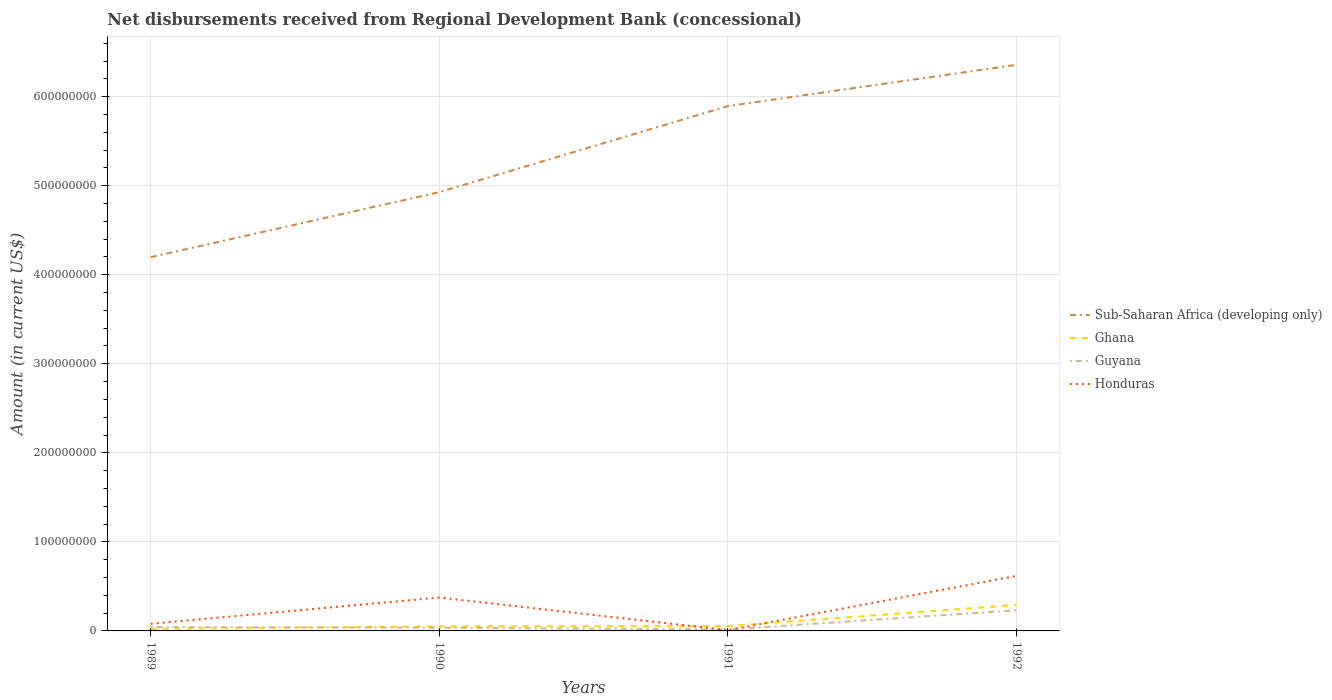How many different coloured lines are there?
Your response must be concise. 4. Is the number of lines equal to the number of legend labels?
Ensure brevity in your answer.  Yes. Across all years, what is the maximum amount of disbursements received from Regional Development Bank in Honduras?
Keep it short and to the point. 9.04e+05. In which year was the amount of disbursements received from Regional Development Bank in Honduras maximum?
Your answer should be very brief. 1991. What is the total amount of disbursements received from Regional Development Bank in Ghana in the graph?
Ensure brevity in your answer.  -2.36e+07. What is the difference between the highest and the second highest amount of disbursements received from Regional Development Bank in Guyana?
Your response must be concise. 2.15e+07. What is the difference between the highest and the lowest amount of disbursements received from Regional Development Bank in Sub-Saharan Africa (developing only)?
Provide a short and direct response. 2. Are the values on the major ticks of Y-axis written in scientific E-notation?
Your answer should be compact. No. Does the graph contain grids?
Provide a short and direct response. Yes. Where does the legend appear in the graph?
Keep it short and to the point. Center right. How many legend labels are there?
Your answer should be compact. 4. How are the legend labels stacked?
Make the answer very short. Vertical. What is the title of the graph?
Keep it short and to the point. Net disbursements received from Regional Development Bank (concessional). Does "Suriname" appear as one of the legend labels in the graph?
Keep it short and to the point. No. What is the label or title of the X-axis?
Offer a very short reply. Years. What is the Amount (in current US$) in Sub-Saharan Africa (developing only) in 1989?
Your answer should be very brief. 4.20e+08. What is the Amount (in current US$) of Ghana in 1989?
Your response must be concise. 2.13e+06. What is the Amount (in current US$) in Guyana in 1989?
Make the answer very short. 4.30e+06. What is the Amount (in current US$) of Honduras in 1989?
Give a very brief answer. 8.04e+06. What is the Amount (in current US$) in Sub-Saharan Africa (developing only) in 1990?
Provide a succinct answer. 4.93e+08. What is the Amount (in current US$) in Ghana in 1990?
Keep it short and to the point. 5.26e+06. What is the Amount (in current US$) of Guyana in 1990?
Your answer should be very brief. 3.54e+06. What is the Amount (in current US$) of Honduras in 1990?
Offer a terse response. 3.75e+07. What is the Amount (in current US$) of Sub-Saharan Africa (developing only) in 1991?
Keep it short and to the point. 5.89e+08. What is the Amount (in current US$) of Ghana in 1991?
Ensure brevity in your answer.  5.51e+06. What is the Amount (in current US$) in Guyana in 1991?
Provide a short and direct response. 1.63e+06. What is the Amount (in current US$) of Honduras in 1991?
Your response must be concise. 9.04e+05. What is the Amount (in current US$) in Sub-Saharan Africa (developing only) in 1992?
Your answer should be compact. 6.36e+08. What is the Amount (in current US$) in Ghana in 1992?
Provide a short and direct response. 2.91e+07. What is the Amount (in current US$) of Guyana in 1992?
Offer a terse response. 2.32e+07. What is the Amount (in current US$) of Honduras in 1992?
Make the answer very short. 6.19e+07. Across all years, what is the maximum Amount (in current US$) of Sub-Saharan Africa (developing only)?
Provide a short and direct response. 6.36e+08. Across all years, what is the maximum Amount (in current US$) in Ghana?
Offer a terse response. 2.91e+07. Across all years, what is the maximum Amount (in current US$) of Guyana?
Your response must be concise. 2.32e+07. Across all years, what is the maximum Amount (in current US$) in Honduras?
Offer a very short reply. 6.19e+07. Across all years, what is the minimum Amount (in current US$) of Sub-Saharan Africa (developing only)?
Give a very brief answer. 4.20e+08. Across all years, what is the minimum Amount (in current US$) of Ghana?
Ensure brevity in your answer.  2.13e+06. Across all years, what is the minimum Amount (in current US$) in Guyana?
Keep it short and to the point. 1.63e+06. Across all years, what is the minimum Amount (in current US$) of Honduras?
Your response must be concise. 9.04e+05. What is the total Amount (in current US$) of Sub-Saharan Africa (developing only) in the graph?
Keep it short and to the point. 2.14e+09. What is the total Amount (in current US$) in Ghana in the graph?
Make the answer very short. 4.20e+07. What is the total Amount (in current US$) in Guyana in the graph?
Offer a terse response. 3.26e+07. What is the total Amount (in current US$) of Honduras in the graph?
Keep it short and to the point. 1.08e+08. What is the difference between the Amount (in current US$) of Sub-Saharan Africa (developing only) in 1989 and that in 1990?
Provide a succinct answer. -7.30e+07. What is the difference between the Amount (in current US$) of Ghana in 1989 and that in 1990?
Your response must be concise. -3.12e+06. What is the difference between the Amount (in current US$) of Guyana in 1989 and that in 1990?
Provide a succinct answer. 7.60e+05. What is the difference between the Amount (in current US$) of Honduras in 1989 and that in 1990?
Provide a succinct answer. -2.95e+07. What is the difference between the Amount (in current US$) of Sub-Saharan Africa (developing only) in 1989 and that in 1991?
Your answer should be compact. -1.70e+08. What is the difference between the Amount (in current US$) of Ghana in 1989 and that in 1991?
Give a very brief answer. -3.38e+06. What is the difference between the Amount (in current US$) of Guyana in 1989 and that in 1991?
Keep it short and to the point. 2.68e+06. What is the difference between the Amount (in current US$) of Honduras in 1989 and that in 1991?
Your answer should be very brief. 7.14e+06. What is the difference between the Amount (in current US$) of Sub-Saharan Africa (developing only) in 1989 and that in 1992?
Your answer should be compact. -2.16e+08. What is the difference between the Amount (in current US$) of Ghana in 1989 and that in 1992?
Make the answer very short. -2.70e+07. What is the difference between the Amount (in current US$) in Guyana in 1989 and that in 1992?
Ensure brevity in your answer.  -1.89e+07. What is the difference between the Amount (in current US$) in Honduras in 1989 and that in 1992?
Provide a succinct answer. -5.38e+07. What is the difference between the Amount (in current US$) of Sub-Saharan Africa (developing only) in 1990 and that in 1991?
Your answer should be compact. -9.66e+07. What is the difference between the Amount (in current US$) in Ghana in 1990 and that in 1991?
Make the answer very short. -2.57e+05. What is the difference between the Amount (in current US$) of Guyana in 1990 and that in 1991?
Offer a very short reply. 1.92e+06. What is the difference between the Amount (in current US$) in Honduras in 1990 and that in 1991?
Make the answer very short. 3.66e+07. What is the difference between the Amount (in current US$) in Sub-Saharan Africa (developing only) in 1990 and that in 1992?
Your answer should be compact. -1.43e+08. What is the difference between the Amount (in current US$) in Ghana in 1990 and that in 1992?
Offer a terse response. -2.39e+07. What is the difference between the Amount (in current US$) of Guyana in 1990 and that in 1992?
Make the answer very short. -1.96e+07. What is the difference between the Amount (in current US$) in Honduras in 1990 and that in 1992?
Offer a terse response. -2.44e+07. What is the difference between the Amount (in current US$) in Sub-Saharan Africa (developing only) in 1991 and that in 1992?
Ensure brevity in your answer.  -4.63e+07. What is the difference between the Amount (in current US$) of Ghana in 1991 and that in 1992?
Provide a short and direct response. -2.36e+07. What is the difference between the Amount (in current US$) of Guyana in 1991 and that in 1992?
Your answer should be compact. -2.15e+07. What is the difference between the Amount (in current US$) in Honduras in 1991 and that in 1992?
Keep it short and to the point. -6.10e+07. What is the difference between the Amount (in current US$) of Sub-Saharan Africa (developing only) in 1989 and the Amount (in current US$) of Ghana in 1990?
Make the answer very short. 4.14e+08. What is the difference between the Amount (in current US$) in Sub-Saharan Africa (developing only) in 1989 and the Amount (in current US$) in Guyana in 1990?
Ensure brevity in your answer.  4.16e+08. What is the difference between the Amount (in current US$) of Sub-Saharan Africa (developing only) in 1989 and the Amount (in current US$) of Honduras in 1990?
Your answer should be very brief. 3.82e+08. What is the difference between the Amount (in current US$) of Ghana in 1989 and the Amount (in current US$) of Guyana in 1990?
Your answer should be very brief. -1.41e+06. What is the difference between the Amount (in current US$) in Ghana in 1989 and the Amount (in current US$) in Honduras in 1990?
Your response must be concise. -3.54e+07. What is the difference between the Amount (in current US$) of Guyana in 1989 and the Amount (in current US$) of Honduras in 1990?
Keep it short and to the point. -3.32e+07. What is the difference between the Amount (in current US$) of Sub-Saharan Africa (developing only) in 1989 and the Amount (in current US$) of Ghana in 1991?
Provide a short and direct response. 4.14e+08. What is the difference between the Amount (in current US$) of Sub-Saharan Africa (developing only) in 1989 and the Amount (in current US$) of Guyana in 1991?
Provide a short and direct response. 4.18e+08. What is the difference between the Amount (in current US$) of Sub-Saharan Africa (developing only) in 1989 and the Amount (in current US$) of Honduras in 1991?
Ensure brevity in your answer.  4.19e+08. What is the difference between the Amount (in current US$) of Ghana in 1989 and the Amount (in current US$) of Guyana in 1991?
Make the answer very short. 5.06e+05. What is the difference between the Amount (in current US$) of Ghana in 1989 and the Amount (in current US$) of Honduras in 1991?
Provide a short and direct response. 1.23e+06. What is the difference between the Amount (in current US$) of Guyana in 1989 and the Amount (in current US$) of Honduras in 1991?
Give a very brief answer. 3.40e+06. What is the difference between the Amount (in current US$) in Sub-Saharan Africa (developing only) in 1989 and the Amount (in current US$) in Ghana in 1992?
Your answer should be compact. 3.91e+08. What is the difference between the Amount (in current US$) of Sub-Saharan Africa (developing only) in 1989 and the Amount (in current US$) of Guyana in 1992?
Provide a short and direct response. 3.97e+08. What is the difference between the Amount (in current US$) of Sub-Saharan Africa (developing only) in 1989 and the Amount (in current US$) of Honduras in 1992?
Offer a very short reply. 3.58e+08. What is the difference between the Amount (in current US$) in Ghana in 1989 and the Amount (in current US$) in Guyana in 1992?
Your answer should be very brief. -2.10e+07. What is the difference between the Amount (in current US$) of Ghana in 1989 and the Amount (in current US$) of Honduras in 1992?
Ensure brevity in your answer.  -5.97e+07. What is the difference between the Amount (in current US$) of Guyana in 1989 and the Amount (in current US$) of Honduras in 1992?
Your response must be concise. -5.76e+07. What is the difference between the Amount (in current US$) of Sub-Saharan Africa (developing only) in 1990 and the Amount (in current US$) of Ghana in 1991?
Make the answer very short. 4.87e+08. What is the difference between the Amount (in current US$) of Sub-Saharan Africa (developing only) in 1990 and the Amount (in current US$) of Guyana in 1991?
Provide a short and direct response. 4.91e+08. What is the difference between the Amount (in current US$) of Sub-Saharan Africa (developing only) in 1990 and the Amount (in current US$) of Honduras in 1991?
Ensure brevity in your answer.  4.92e+08. What is the difference between the Amount (in current US$) of Ghana in 1990 and the Amount (in current US$) of Guyana in 1991?
Make the answer very short. 3.63e+06. What is the difference between the Amount (in current US$) of Ghana in 1990 and the Amount (in current US$) of Honduras in 1991?
Provide a succinct answer. 4.35e+06. What is the difference between the Amount (in current US$) of Guyana in 1990 and the Amount (in current US$) of Honduras in 1991?
Give a very brief answer. 2.64e+06. What is the difference between the Amount (in current US$) of Sub-Saharan Africa (developing only) in 1990 and the Amount (in current US$) of Ghana in 1992?
Your answer should be very brief. 4.64e+08. What is the difference between the Amount (in current US$) of Sub-Saharan Africa (developing only) in 1990 and the Amount (in current US$) of Guyana in 1992?
Make the answer very short. 4.70e+08. What is the difference between the Amount (in current US$) in Sub-Saharan Africa (developing only) in 1990 and the Amount (in current US$) in Honduras in 1992?
Offer a very short reply. 4.31e+08. What is the difference between the Amount (in current US$) of Ghana in 1990 and the Amount (in current US$) of Guyana in 1992?
Provide a short and direct response. -1.79e+07. What is the difference between the Amount (in current US$) in Ghana in 1990 and the Amount (in current US$) in Honduras in 1992?
Ensure brevity in your answer.  -5.66e+07. What is the difference between the Amount (in current US$) in Guyana in 1990 and the Amount (in current US$) in Honduras in 1992?
Provide a succinct answer. -5.83e+07. What is the difference between the Amount (in current US$) of Sub-Saharan Africa (developing only) in 1991 and the Amount (in current US$) of Ghana in 1992?
Provide a short and direct response. 5.60e+08. What is the difference between the Amount (in current US$) in Sub-Saharan Africa (developing only) in 1991 and the Amount (in current US$) in Guyana in 1992?
Make the answer very short. 5.66e+08. What is the difference between the Amount (in current US$) in Sub-Saharan Africa (developing only) in 1991 and the Amount (in current US$) in Honduras in 1992?
Offer a very short reply. 5.28e+08. What is the difference between the Amount (in current US$) in Ghana in 1991 and the Amount (in current US$) in Guyana in 1992?
Make the answer very short. -1.77e+07. What is the difference between the Amount (in current US$) of Ghana in 1991 and the Amount (in current US$) of Honduras in 1992?
Provide a short and direct response. -5.64e+07. What is the difference between the Amount (in current US$) in Guyana in 1991 and the Amount (in current US$) in Honduras in 1992?
Offer a very short reply. -6.02e+07. What is the average Amount (in current US$) in Sub-Saharan Africa (developing only) per year?
Your response must be concise. 5.34e+08. What is the average Amount (in current US$) of Ghana per year?
Your response must be concise. 1.05e+07. What is the average Amount (in current US$) in Guyana per year?
Your answer should be compact. 8.16e+06. What is the average Amount (in current US$) of Honduras per year?
Provide a short and direct response. 2.71e+07. In the year 1989, what is the difference between the Amount (in current US$) in Sub-Saharan Africa (developing only) and Amount (in current US$) in Ghana?
Keep it short and to the point. 4.18e+08. In the year 1989, what is the difference between the Amount (in current US$) of Sub-Saharan Africa (developing only) and Amount (in current US$) of Guyana?
Keep it short and to the point. 4.15e+08. In the year 1989, what is the difference between the Amount (in current US$) of Sub-Saharan Africa (developing only) and Amount (in current US$) of Honduras?
Make the answer very short. 4.12e+08. In the year 1989, what is the difference between the Amount (in current US$) of Ghana and Amount (in current US$) of Guyana?
Ensure brevity in your answer.  -2.17e+06. In the year 1989, what is the difference between the Amount (in current US$) in Ghana and Amount (in current US$) in Honduras?
Your answer should be very brief. -5.91e+06. In the year 1989, what is the difference between the Amount (in current US$) in Guyana and Amount (in current US$) in Honduras?
Make the answer very short. -3.74e+06. In the year 1990, what is the difference between the Amount (in current US$) of Sub-Saharan Africa (developing only) and Amount (in current US$) of Ghana?
Provide a succinct answer. 4.87e+08. In the year 1990, what is the difference between the Amount (in current US$) of Sub-Saharan Africa (developing only) and Amount (in current US$) of Guyana?
Your answer should be very brief. 4.89e+08. In the year 1990, what is the difference between the Amount (in current US$) in Sub-Saharan Africa (developing only) and Amount (in current US$) in Honduras?
Offer a very short reply. 4.55e+08. In the year 1990, what is the difference between the Amount (in current US$) in Ghana and Amount (in current US$) in Guyana?
Provide a short and direct response. 1.71e+06. In the year 1990, what is the difference between the Amount (in current US$) in Ghana and Amount (in current US$) in Honduras?
Your response must be concise. -3.22e+07. In the year 1990, what is the difference between the Amount (in current US$) of Guyana and Amount (in current US$) of Honduras?
Your response must be concise. -3.40e+07. In the year 1991, what is the difference between the Amount (in current US$) in Sub-Saharan Africa (developing only) and Amount (in current US$) in Ghana?
Your answer should be very brief. 5.84e+08. In the year 1991, what is the difference between the Amount (in current US$) of Sub-Saharan Africa (developing only) and Amount (in current US$) of Guyana?
Offer a terse response. 5.88e+08. In the year 1991, what is the difference between the Amount (in current US$) of Sub-Saharan Africa (developing only) and Amount (in current US$) of Honduras?
Ensure brevity in your answer.  5.88e+08. In the year 1991, what is the difference between the Amount (in current US$) of Ghana and Amount (in current US$) of Guyana?
Make the answer very short. 3.89e+06. In the year 1991, what is the difference between the Amount (in current US$) in Ghana and Amount (in current US$) in Honduras?
Make the answer very short. 4.61e+06. In the year 1991, what is the difference between the Amount (in current US$) in Guyana and Amount (in current US$) in Honduras?
Give a very brief answer. 7.24e+05. In the year 1992, what is the difference between the Amount (in current US$) of Sub-Saharan Africa (developing only) and Amount (in current US$) of Ghana?
Offer a very short reply. 6.07e+08. In the year 1992, what is the difference between the Amount (in current US$) in Sub-Saharan Africa (developing only) and Amount (in current US$) in Guyana?
Your answer should be compact. 6.13e+08. In the year 1992, what is the difference between the Amount (in current US$) in Sub-Saharan Africa (developing only) and Amount (in current US$) in Honduras?
Ensure brevity in your answer.  5.74e+08. In the year 1992, what is the difference between the Amount (in current US$) of Ghana and Amount (in current US$) of Guyana?
Keep it short and to the point. 5.97e+06. In the year 1992, what is the difference between the Amount (in current US$) of Ghana and Amount (in current US$) of Honduras?
Offer a very short reply. -3.27e+07. In the year 1992, what is the difference between the Amount (in current US$) in Guyana and Amount (in current US$) in Honduras?
Provide a succinct answer. -3.87e+07. What is the ratio of the Amount (in current US$) of Sub-Saharan Africa (developing only) in 1989 to that in 1990?
Your answer should be compact. 0.85. What is the ratio of the Amount (in current US$) in Ghana in 1989 to that in 1990?
Your response must be concise. 0.41. What is the ratio of the Amount (in current US$) of Guyana in 1989 to that in 1990?
Offer a terse response. 1.21. What is the ratio of the Amount (in current US$) in Honduras in 1989 to that in 1990?
Your response must be concise. 0.21. What is the ratio of the Amount (in current US$) of Sub-Saharan Africa (developing only) in 1989 to that in 1991?
Your answer should be compact. 0.71. What is the ratio of the Amount (in current US$) of Ghana in 1989 to that in 1991?
Keep it short and to the point. 0.39. What is the ratio of the Amount (in current US$) in Guyana in 1989 to that in 1991?
Keep it short and to the point. 2.64. What is the ratio of the Amount (in current US$) of Honduras in 1989 to that in 1991?
Provide a short and direct response. 8.89. What is the ratio of the Amount (in current US$) of Sub-Saharan Africa (developing only) in 1989 to that in 1992?
Your response must be concise. 0.66. What is the ratio of the Amount (in current US$) in Ghana in 1989 to that in 1992?
Offer a very short reply. 0.07. What is the ratio of the Amount (in current US$) of Guyana in 1989 to that in 1992?
Your response must be concise. 0.19. What is the ratio of the Amount (in current US$) of Honduras in 1989 to that in 1992?
Ensure brevity in your answer.  0.13. What is the ratio of the Amount (in current US$) of Sub-Saharan Africa (developing only) in 1990 to that in 1991?
Provide a succinct answer. 0.84. What is the ratio of the Amount (in current US$) of Ghana in 1990 to that in 1991?
Give a very brief answer. 0.95. What is the ratio of the Amount (in current US$) of Guyana in 1990 to that in 1991?
Make the answer very short. 2.18. What is the ratio of the Amount (in current US$) in Honduras in 1990 to that in 1991?
Offer a terse response. 41.48. What is the ratio of the Amount (in current US$) in Sub-Saharan Africa (developing only) in 1990 to that in 1992?
Ensure brevity in your answer.  0.78. What is the ratio of the Amount (in current US$) of Ghana in 1990 to that in 1992?
Your answer should be compact. 0.18. What is the ratio of the Amount (in current US$) of Guyana in 1990 to that in 1992?
Give a very brief answer. 0.15. What is the ratio of the Amount (in current US$) of Honduras in 1990 to that in 1992?
Make the answer very short. 0.61. What is the ratio of the Amount (in current US$) in Sub-Saharan Africa (developing only) in 1991 to that in 1992?
Provide a short and direct response. 0.93. What is the ratio of the Amount (in current US$) of Ghana in 1991 to that in 1992?
Ensure brevity in your answer.  0.19. What is the ratio of the Amount (in current US$) of Guyana in 1991 to that in 1992?
Offer a terse response. 0.07. What is the ratio of the Amount (in current US$) of Honduras in 1991 to that in 1992?
Provide a succinct answer. 0.01. What is the difference between the highest and the second highest Amount (in current US$) in Sub-Saharan Africa (developing only)?
Ensure brevity in your answer.  4.63e+07. What is the difference between the highest and the second highest Amount (in current US$) of Ghana?
Give a very brief answer. 2.36e+07. What is the difference between the highest and the second highest Amount (in current US$) in Guyana?
Make the answer very short. 1.89e+07. What is the difference between the highest and the second highest Amount (in current US$) in Honduras?
Provide a succinct answer. 2.44e+07. What is the difference between the highest and the lowest Amount (in current US$) in Sub-Saharan Africa (developing only)?
Your answer should be very brief. 2.16e+08. What is the difference between the highest and the lowest Amount (in current US$) of Ghana?
Your response must be concise. 2.70e+07. What is the difference between the highest and the lowest Amount (in current US$) of Guyana?
Your answer should be very brief. 2.15e+07. What is the difference between the highest and the lowest Amount (in current US$) in Honduras?
Provide a short and direct response. 6.10e+07. 